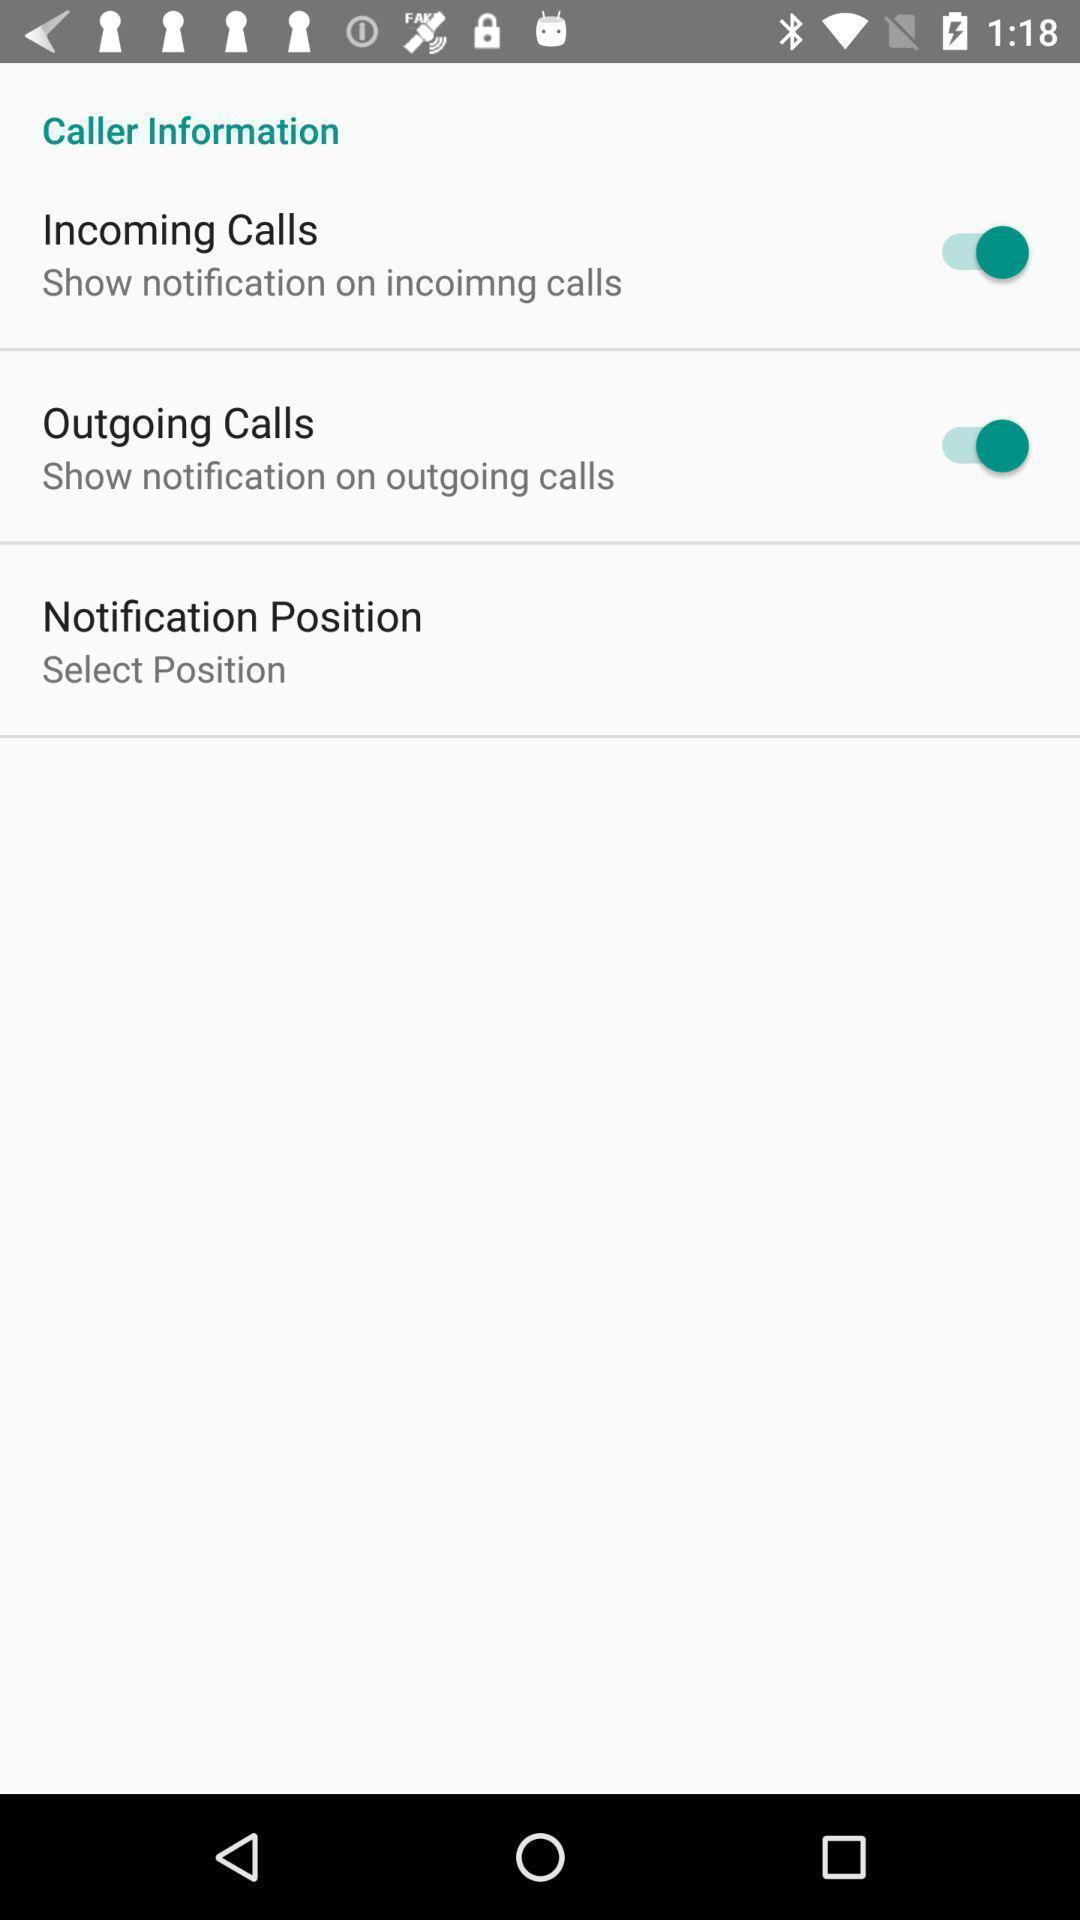Summarize the main components in this picture. Screen displaying the caller information. 